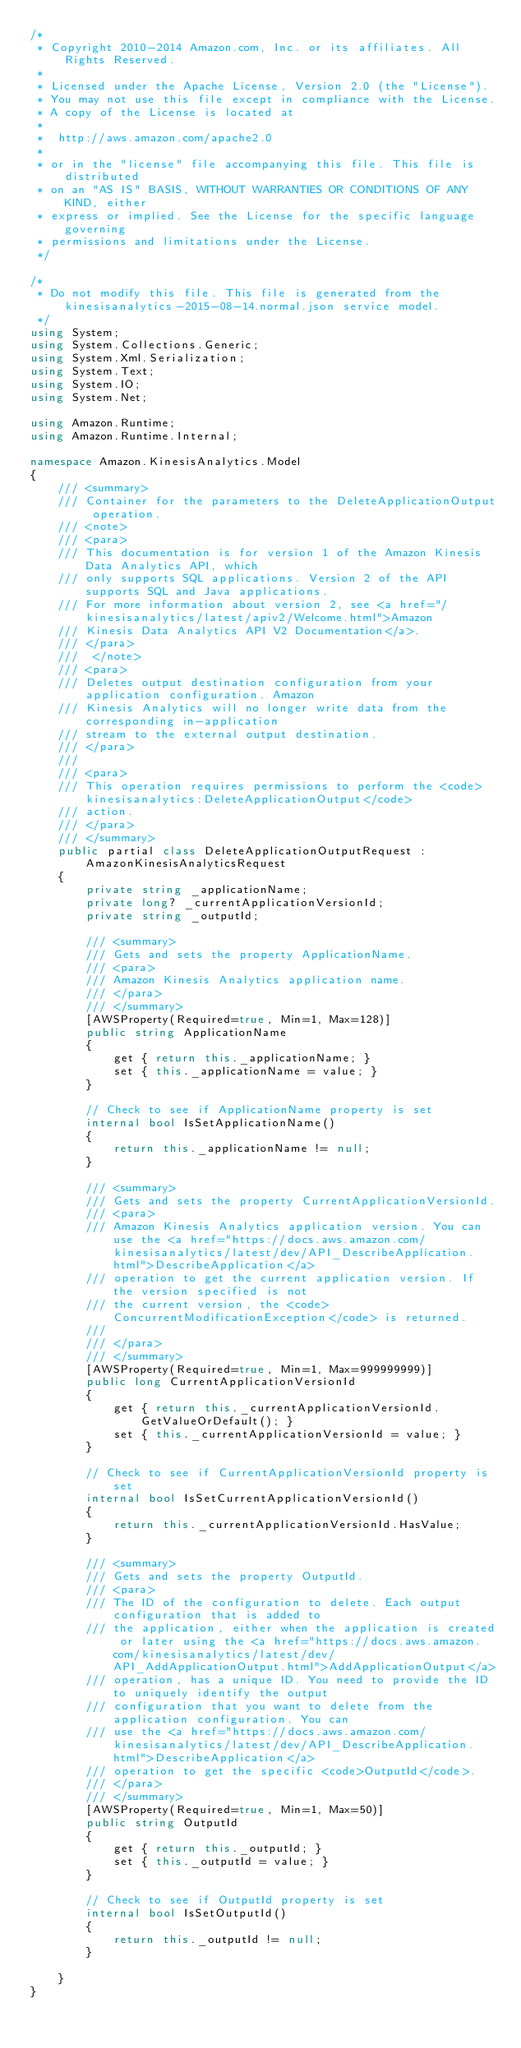Convert code to text. <code><loc_0><loc_0><loc_500><loc_500><_C#_>/*
 * Copyright 2010-2014 Amazon.com, Inc. or its affiliates. All Rights Reserved.
 * 
 * Licensed under the Apache License, Version 2.0 (the "License").
 * You may not use this file except in compliance with the License.
 * A copy of the License is located at
 * 
 *  http://aws.amazon.com/apache2.0
 * 
 * or in the "license" file accompanying this file. This file is distributed
 * on an "AS IS" BASIS, WITHOUT WARRANTIES OR CONDITIONS OF ANY KIND, either
 * express or implied. See the License for the specific language governing
 * permissions and limitations under the License.
 */

/*
 * Do not modify this file. This file is generated from the kinesisanalytics-2015-08-14.normal.json service model.
 */
using System;
using System.Collections.Generic;
using System.Xml.Serialization;
using System.Text;
using System.IO;
using System.Net;

using Amazon.Runtime;
using Amazon.Runtime.Internal;

namespace Amazon.KinesisAnalytics.Model
{
    /// <summary>
    /// Container for the parameters to the DeleteApplicationOutput operation.
    /// <note> 
    /// <para>
    /// This documentation is for version 1 of the Amazon Kinesis Data Analytics API, which
    /// only supports SQL applications. Version 2 of the API supports SQL and Java applications.
    /// For more information about version 2, see <a href="/kinesisanalytics/latest/apiv2/Welcome.html">Amazon
    /// Kinesis Data Analytics API V2 Documentation</a>.
    /// </para>
    ///  </note> 
    /// <para>
    /// Deletes output destination configuration from your application configuration. Amazon
    /// Kinesis Analytics will no longer write data from the corresponding in-application
    /// stream to the external output destination.
    /// </para>
    ///  
    /// <para>
    /// This operation requires permissions to perform the <code>kinesisanalytics:DeleteApplicationOutput</code>
    /// action.
    /// </para>
    /// </summary>
    public partial class DeleteApplicationOutputRequest : AmazonKinesisAnalyticsRequest
    {
        private string _applicationName;
        private long? _currentApplicationVersionId;
        private string _outputId;

        /// <summary>
        /// Gets and sets the property ApplicationName. 
        /// <para>
        /// Amazon Kinesis Analytics application name.
        /// </para>
        /// </summary>
        [AWSProperty(Required=true, Min=1, Max=128)]
        public string ApplicationName
        {
            get { return this._applicationName; }
            set { this._applicationName = value; }
        }

        // Check to see if ApplicationName property is set
        internal bool IsSetApplicationName()
        {
            return this._applicationName != null;
        }

        /// <summary>
        /// Gets and sets the property CurrentApplicationVersionId. 
        /// <para>
        /// Amazon Kinesis Analytics application version. You can use the <a href="https://docs.aws.amazon.com/kinesisanalytics/latest/dev/API_DescribeApplication.html">DescribeApplication</a>
        /// operation to get the current application version. If the version specified is not
        /// the current version, the <code>ConcurrentModificationException</code> is returned.
        /// 
        /// </para>
        /// </summary>
        [AWSProperty(Required=true, Min=1, Max=999999999)]
        public long CurrentApplicationVersionId
        {
            get { return this._currentApplicationVersionId.GetValueOrDefault(); }
            set { this._currentApplicationVersionId = value; }
        }

        // Check to see if CurrentApplicationVersionId property is set
        internal bool IsSetCurrentApplicationVersionId()
        {
            return this._currentApplicationVersionId.HasValue; 
        }

        /// <summary>
        /// Gets and sets the property OutputId. 
        /// <para>
        /// The ID of the configuration to delete. Each output configuration that is added to
        /// the application, either when the application is created or later using the <a href="https://docs.aws.amazon.com/kinesisanalytics/latest/dev/API_AddApplicationOutput.html">AddApplicationOutput</a>
        /// operation, has a unique ID. You need to provide the ID to uniquely identify the output
        /// configuration that you want to delete from the application configuration. You can
        /// use the <a href="https://docs.aws.amazon.com/kinesisanalytics/latest/dev/API_DescribeApplication.html">DescribeApplication</a>
        /// operation to get the specific <code>OutputId</code>. 
        /// </para>
        /// </summary>
        [AWSProperty(Required=true, Min=1, Max=50)]
        public string OutputId
        {
            get { return this._outputId; }
            set { this._outputId = value; }
        }

        // Check to see if OutputId property is set
        internal bool IsSetOutputId()
        {
            return this._outputId != null;
        }

    }
}</code> 